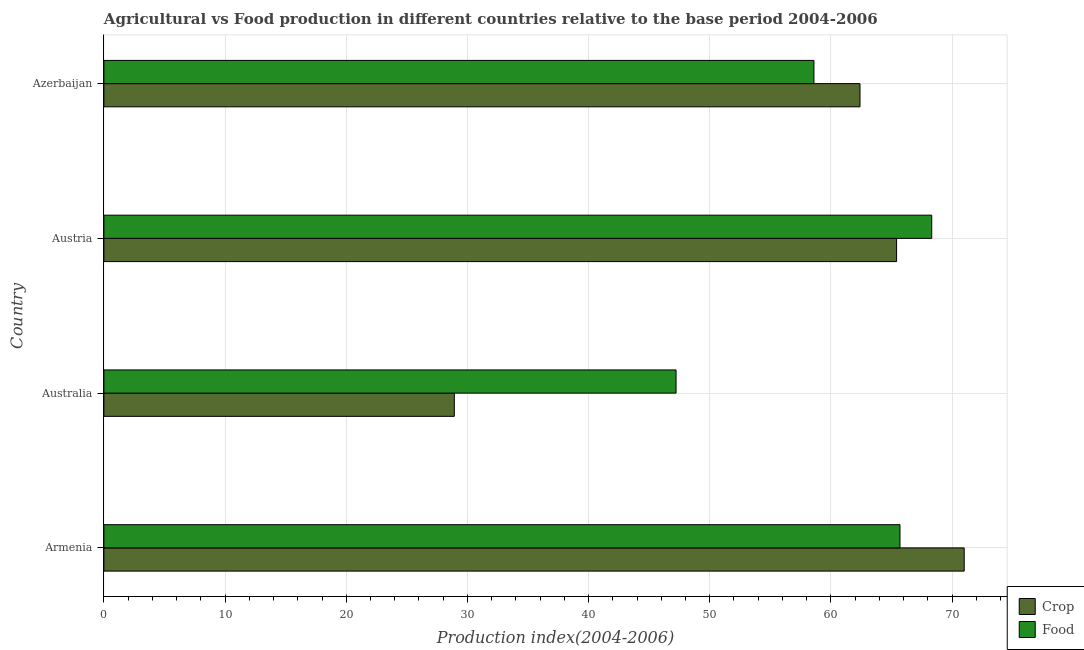How many different coloured bars are there?
Make the answer very short. 2. How many groups of bars are there?
Offer a terse response. 4. Are the number of bars per tick equal to the number of legend labels?
Make the answer very short. Yes. Are the number of bars on each tick of the Y-axis equal?
Your answer should be compact. Yes. How many bars are there on the 2nd tick from the top?
Ensure brevity in your answer.  2. What is the label of the 2nd group of bars from the top?
Your answer should be very brief. Austria. What is the food production index in Austria?
Ensure brevity in your answer.  68.32. Across all countries, what is the minimum crop production index?
Ensure brevity in your answer.  28.92. In which country was the food production index maximum?
Your answer should be compact. Austria. In which country was the food production index minimum?
Your response must be concise. Australia. What is the total food production index in the graph?
Your response must be concise. 239.84. What is the difference between the crop production index in Armenia and that in Austria?
Offer a very short reply. 5.58. What is the difference between the crop production index in Armenia and the food production index in Azerbaijan?
Your answer should be very brief. 12.4. What is the average food production index per country?
Give a very brief answer. 59.96. What is the difference between the crop production index and food production index in Australia?
Offer a very short reply. -18.3. In how many countries, is the food production index greater than 44 ?
Offer a very short reply. 4. What is the ratio of the crop production index in Armenia to that in Austria?
Your answer should be compact. 1.08. Is the crop production index in Australia less than that in Azerbaijan?
Your answer should be compact. Yes. Is the difference between the crop production index in Australia and Austria greater than the difference between the food production index in Australia and Austria?
Offer a terse response. No. What is the difference between the highest and the second highest food production index?
Provide a short and direct response. 2.62. What is the difference between the highest and the lowest crop production index?
Offer a terse response. 42.08. What does the 1st bar from the top in Austria represents?
Offer a very short reply. Food. What does the 1st bar from the bottom in Armenia represents?
Give a very brief answer. Crop. Are the values on the major ticks of X-axis written in scientific E-notation?
Ensure brevity in your answer.  No. Does the graph contain any zero values?
Your response must be concise. No. Does the graph contain grids?
Give a very brief answer. Yes. What is the title of the graph?
Keep it short and to the point. Agricultural vs Food production in different countries relative to the base period 2004-2006. Does "Non-pregnant women" appear as one of the legend labels in the graph?
Your response must be concise. No. What is the label or title of the X-axis?
Your response must be concise. Production index(2004-2006). What is the Production index(2004-2006) in Crop in Armenia?
Ensure brevity in your answer.  71. What is the Production index(2004-2006) in Food in Armenia?
Offer a terse response. 65.7. What is the Production index(2004-2006) of Crop in Australia?
Make the answer very short. 28.92. What is the Production index(2004-2006) in Food in Australia?
Give a very brief answer. 47.22. What is the Production index(2004-2006) of Crop in Austria?
Keep it short and to the point. 65.42. What is the Production index(2004-2006) in Food in Austria?
Your answer should be compact. 68.32. What is the Production index(2004-2006) of Crop in Azerbaijan?
Provide a short and direct response. 62.4. What is the Production index(2004-2006) of Food in Azerbaijan?
Offer a terse response. 58.6. Across all countries, what is the maximum Production index(2004-2006) in Crop?
Give a very brief answer. 71. Across all countries, what is the maximum Production index(2004-2006) of Food?
Your answer should be compact. 68.32. Across all countries, what is the minimum Production index(2004-2006) in Crop?
Make the answer very short. 28.92. Across all countries, what is the minimum Production index(2004-2006) of Food?
Give a very brief answer. 47.22. What is the total Production index(2004-2006) in Crop in the graph?
Ensure brevity in your answer.  227.74. What is the total Production index(2004-2006) in Food in the graph?
Ensure brevity in your answer.  239.84. What is the difference between the Production index(2004-2006) in Crop in Armenia and that in Australia?
Provide a short and direct response. 42.08. What is the difference between the Production index(2004-2006) of Food in Armenia and that in Australia?
Your answer should be very brief. 18.48. What is the difference between the Production index(2004-2006) in Crop in Armenia and that in Austria?
Provide a short and direct response. 5.58. What is the difference between the Production index(2004-2006) of Food in Armenia and that in Austria?
Provide a succinct answer. -2.62. What is the difference between the Production index(2004-2006) of Crop in Armenia and that in Azerbaijan?
Your answer should be compact. 8.6. What is the difference between the Production index(2004-2006) in Food in Armenia and that in Azerbaijan?
Your answer should be compact. 7.1. What is the difference between the Production index(2004-2006) of Crop in Australia and that in Austria?
Your answer should be very brief. -36.5. What is the difference between the Production index(2004-2006) of Food in Australia and that in Austria?
Give a very brief answer. -21.1. What is the difference between the Production index(2004-2006) in Crop in Australia and that in Azerbaijan?
Make the answer very short. -33.48. What is the difference between the Production index(2004-2006) in Food in Australia and that in Azerbaijan?
Provide a short and direct response. -11.38. What is the difference between the Production index(2004-2006) of Crop in Austria and that in Azerbaijan?
Provide a succinct answer. 3.02. What is the difference between the Production index(2004-2006) of Food in Austria and that in Azerbaijan?
Make the answer very short. 9.72. What is the difference between the Production index(2004-2006) of Crop in Armenia and the Production index(2004-2006) of Food in Australia?
Provide a succinct answer. 23.78. What is the difference between the Production index(2004-2006) in Crop in Armenia and the Production index(2004-2006) in Food in Austria?
Your answer should be very brief. 2.68. What is the difference between the Production index(2004-2006) in Crop in Armenia and the Production index(2004-2006) in Food in Azerbaijan?
Ensure brevity in your answer.  12.4. What is the difference between the Production index(2004-2006) in Crop in Australia and the Production index(2004-2006) in Food in Austria?
Ensure brevity in your answer.  -39.4. What is the difference between the Production index(2004-2006) of Crop in Australia and the Production index(2004-2006) of Food in Azerbaijan?
Offer a very short reply. -29.68. What is the difference between the Production index(2004-2006) in Crop in Austria and the Production index(2004-2006) in Food in Azerbaijan?
Provide a succinct answer. 6.82. What is the average Production index(2004-2006) of Crop per country?
Offer a very short reply. 56.94. What is the average Production index(2004-2006) in Food per country?
Your response must be concise. 59.96. What is the difference between the Production index(2004-2006) of Crop and Production index(2004-2006) of Food in Armenia?
Your answer should be very brief. 5.3. What is the difference between the Production index(2004-2006) in Crop and Production index(2004-2006) in Food in Australia?
Your response must be concise. -18.3. What is the difference between the Production index(2004-2006) in Crop and Production index(2004-2006) in Food in Austria?
Make the answer very short. -2.9. What is the ratio of the Production index(2004-2006) of Crop in Armenia to that in Australia?
Your answer should be compact. 2.46. What is the ratio of the Production index(2004-2006) in Food in Armenia to that in Australia?
Your answer should be compact. 1.39. What is the ratio of the Production index(2004-2006) in Crop in Armenia to that in Austria?
Your answer should be compact. 1.09. What is the ratio of the Production index(2004-2006) of Food in Armenia to that in Austria?
Your answer should be very brief. 0.96. What is the ratio of the Production index(2004-2006) of Crop in Armenia to that in Azerbaijan?
Ensure brevity in your answer.  1.14. What is the ratio of the Production index(2004-2006) of Food in Armenia to that in Azerbaijan?
Your response must be concise. 1.12. What is the ratio of the Production index(2004-2006) of Crop in Australia to that in Austria?
Provide a short and direct response. 0.44. What is the ratio of the Production index(2004-2006) in Food in Australia to that in Austria?
Provide a succinct answer. 0.69. What is the ratio of the Production index(2004-2006) in Crop in Australia to that in Azerbaijan?
Offer a terse response. 0.46. What is the ratio of the Production index(2004-2006) of Food in Australia to that in Azerbaijan?
Your answer should be compact. 0.81. What is the ratio of the Production index(2004-2006) of Crop in Austria to that in Azerbaijan?
Your answer should be compact. 1.05. What is the ratio of the Production index(2004-2006) of Food in Austria to that in Azerbaijan?
Keep it short and to the point. 1.17. What is the difference between the highest and the second highest Production index(2004-2006) in Crop?
Give a very brief answer. 5.58. What is the difference between the highest and the second highest Production index(2004-2006) of Food?
Offer a very short reply. 2.62. What is the difference between the highest and the lowest Production index(2004-2006) of Crop?
Your answer should be very brief. 42.08. What is the difference between the highest and the lowest Production index(2004-2006) in Food?
Provide a succinct answer. 21.1. 